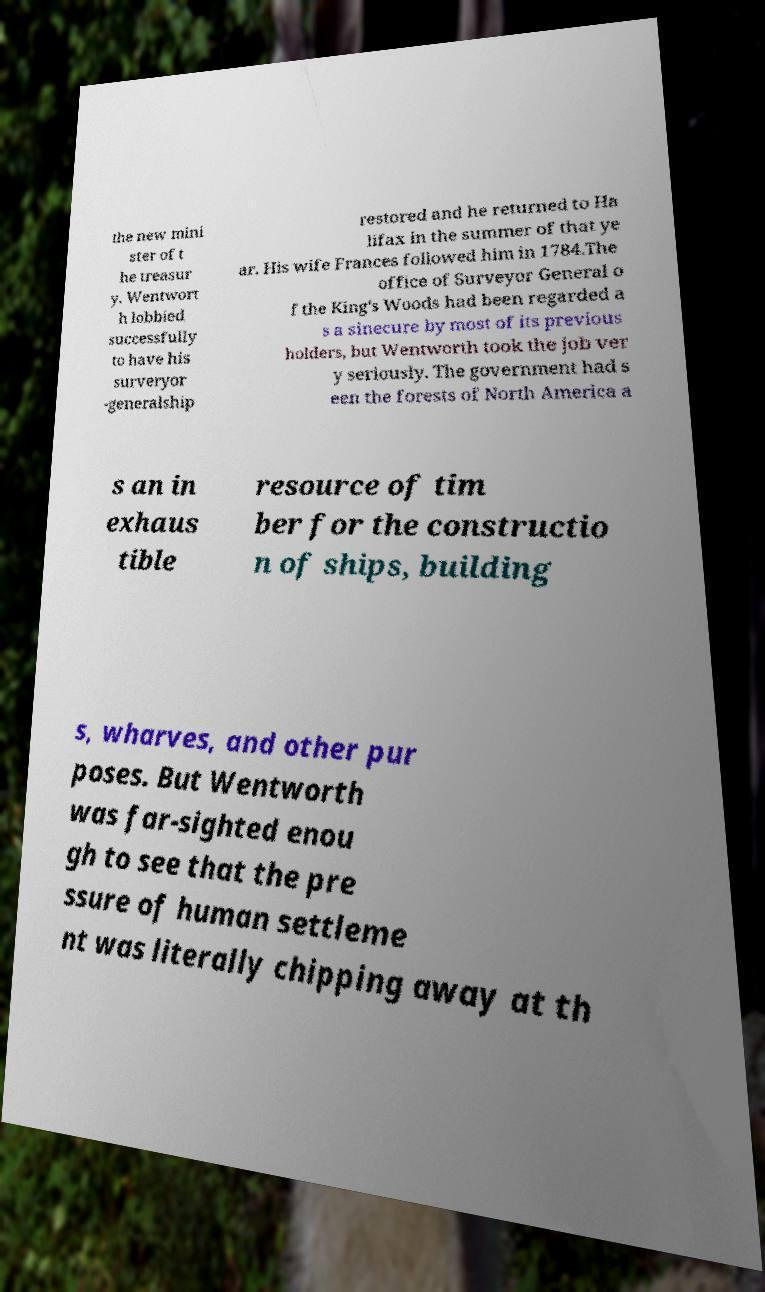There's text embedded in this image that I need extracted. Can you transcribe it verbatim? the new mini ster of t he treasur y. Wentwort h lobbied successfully to have his surveryor -generalship restored and he returned to Ha lifax in the summer of that ye ar. His wife Frances followed him in 1784.The office of Surveyor General o f the King's Woods had been regarded a s a sinecure by most of its previous holders, but Wentworth took the job ver y seriously. The government had s een the forests of North America a s an in exhaus tible resource of tim ber for the constructio n of ships, building s, wharves, and other pur poses. But Wentworth was far-sighted enou gh to see that the pre ssure of human settleme nt was literally chipping away at th 